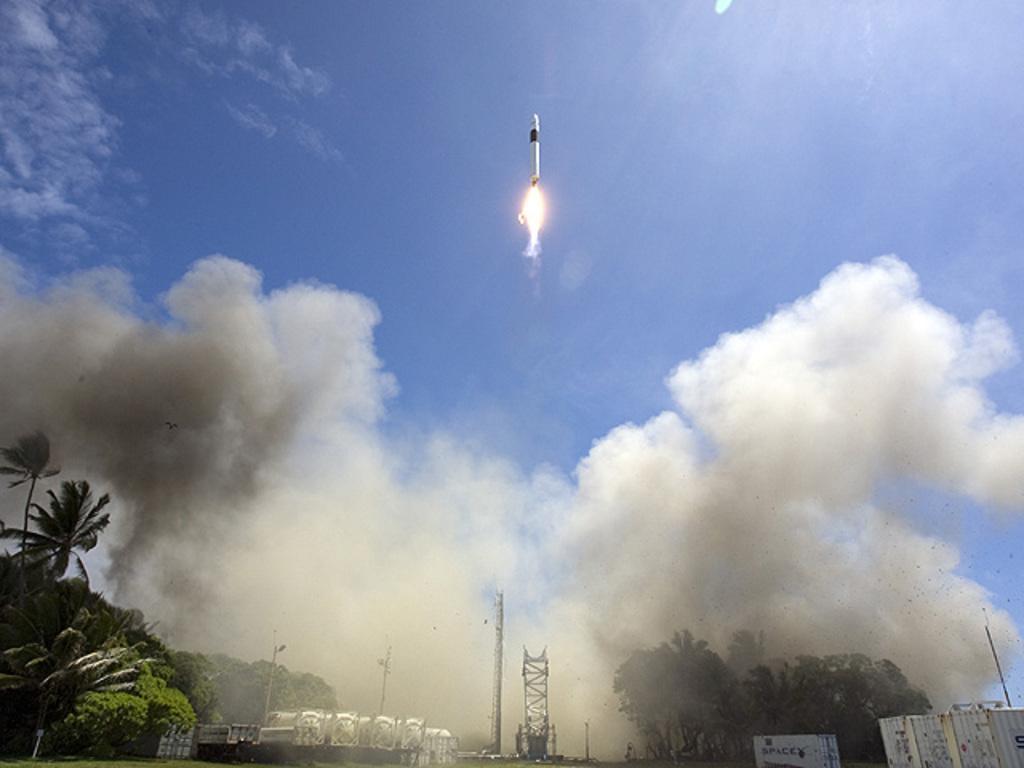In one or two sentences, can you explain what this image depicts? In this image we can see a missile flying in the sky. In the background we can see group of trees ,buildings ,containers and cloudy sky. 